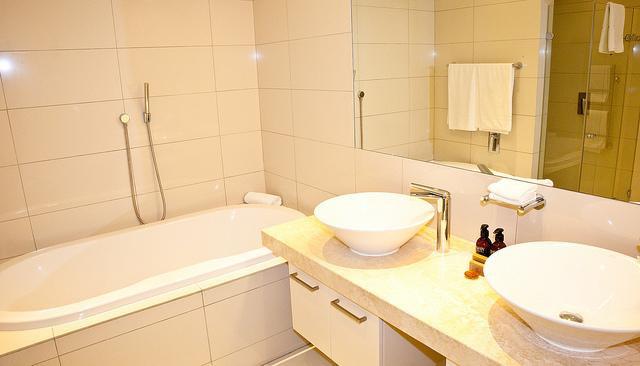What type of sinks are these? bowl 